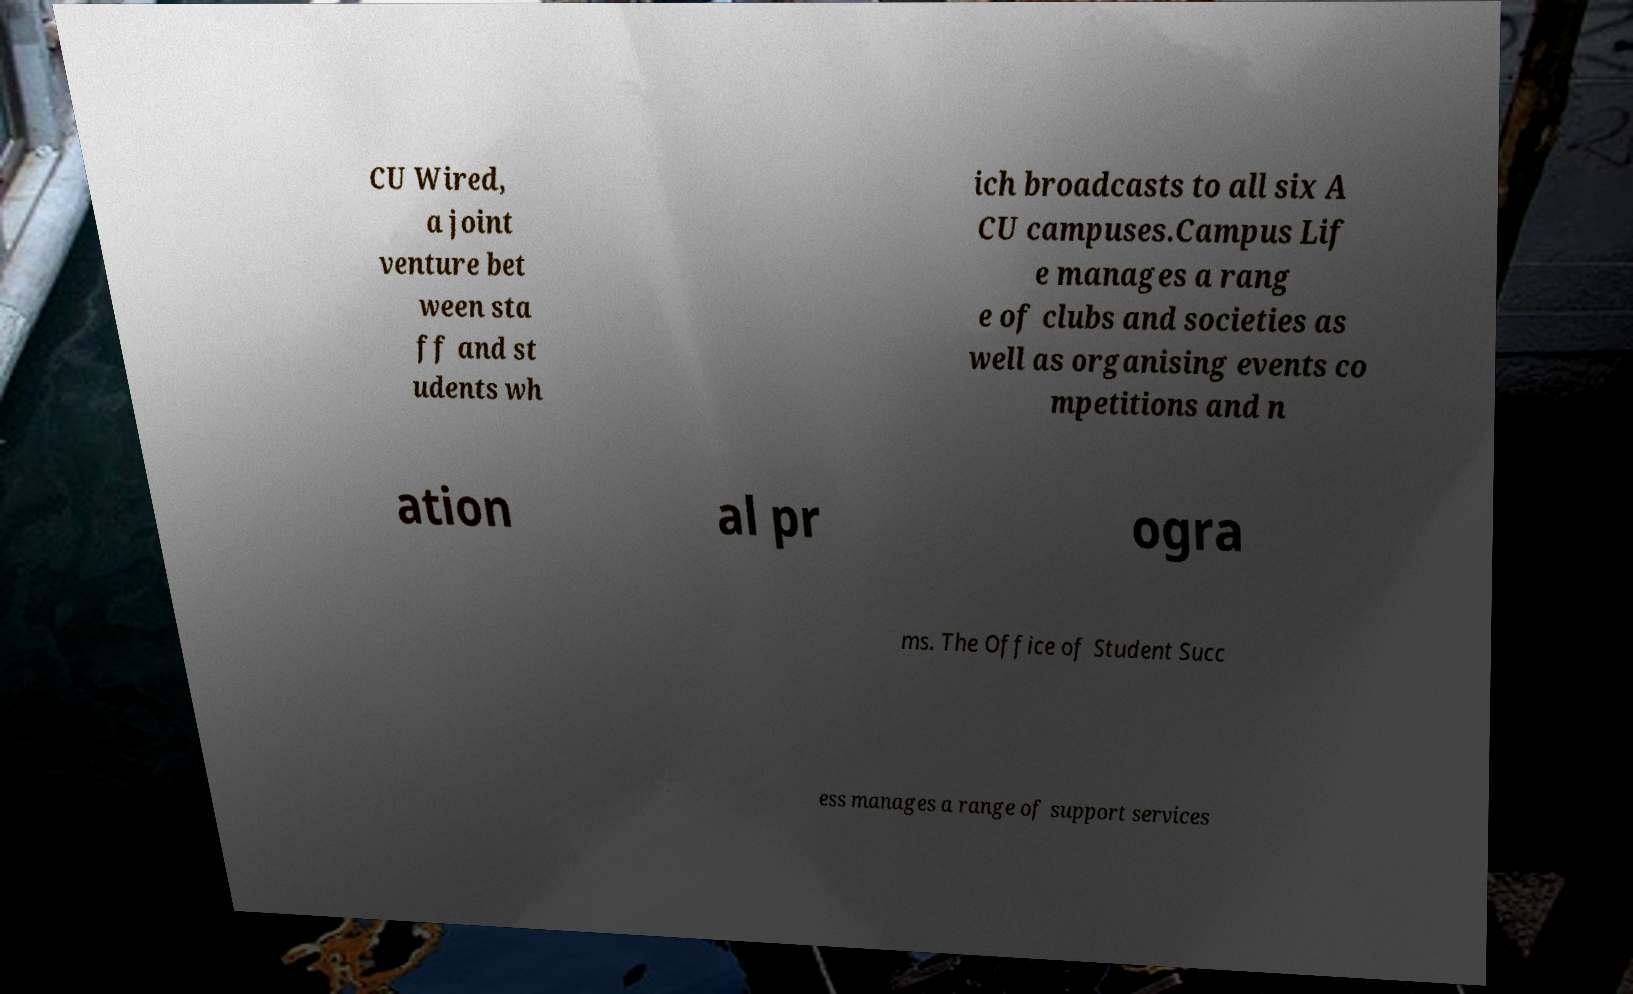Can you accurately transcribe the text from the provided image for me? CU Wired, a joint venture bet ween sta ff and st udents wh ich broadcasts to all six A CU campuses.Campus Lif e manages a rang e of clubs and societies as well as organising events co mpetitions and n ation al pr ogra ms. The Office of Student Succ ess manages a range of support services 